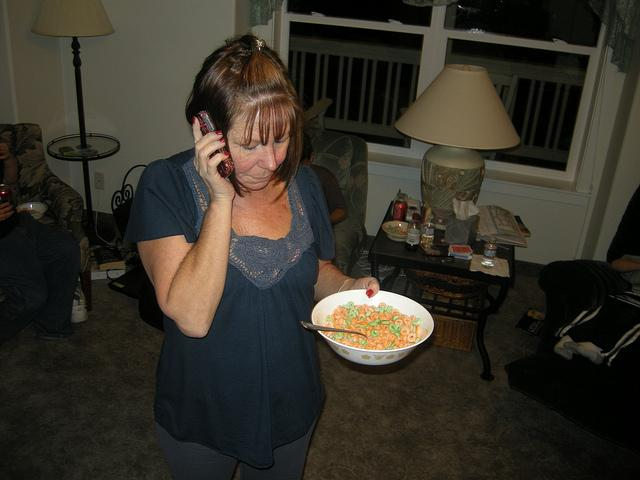What age group normally eats this food?

Choices:
A) young adults
B) teenagers
C) kids
D) seniors kids 